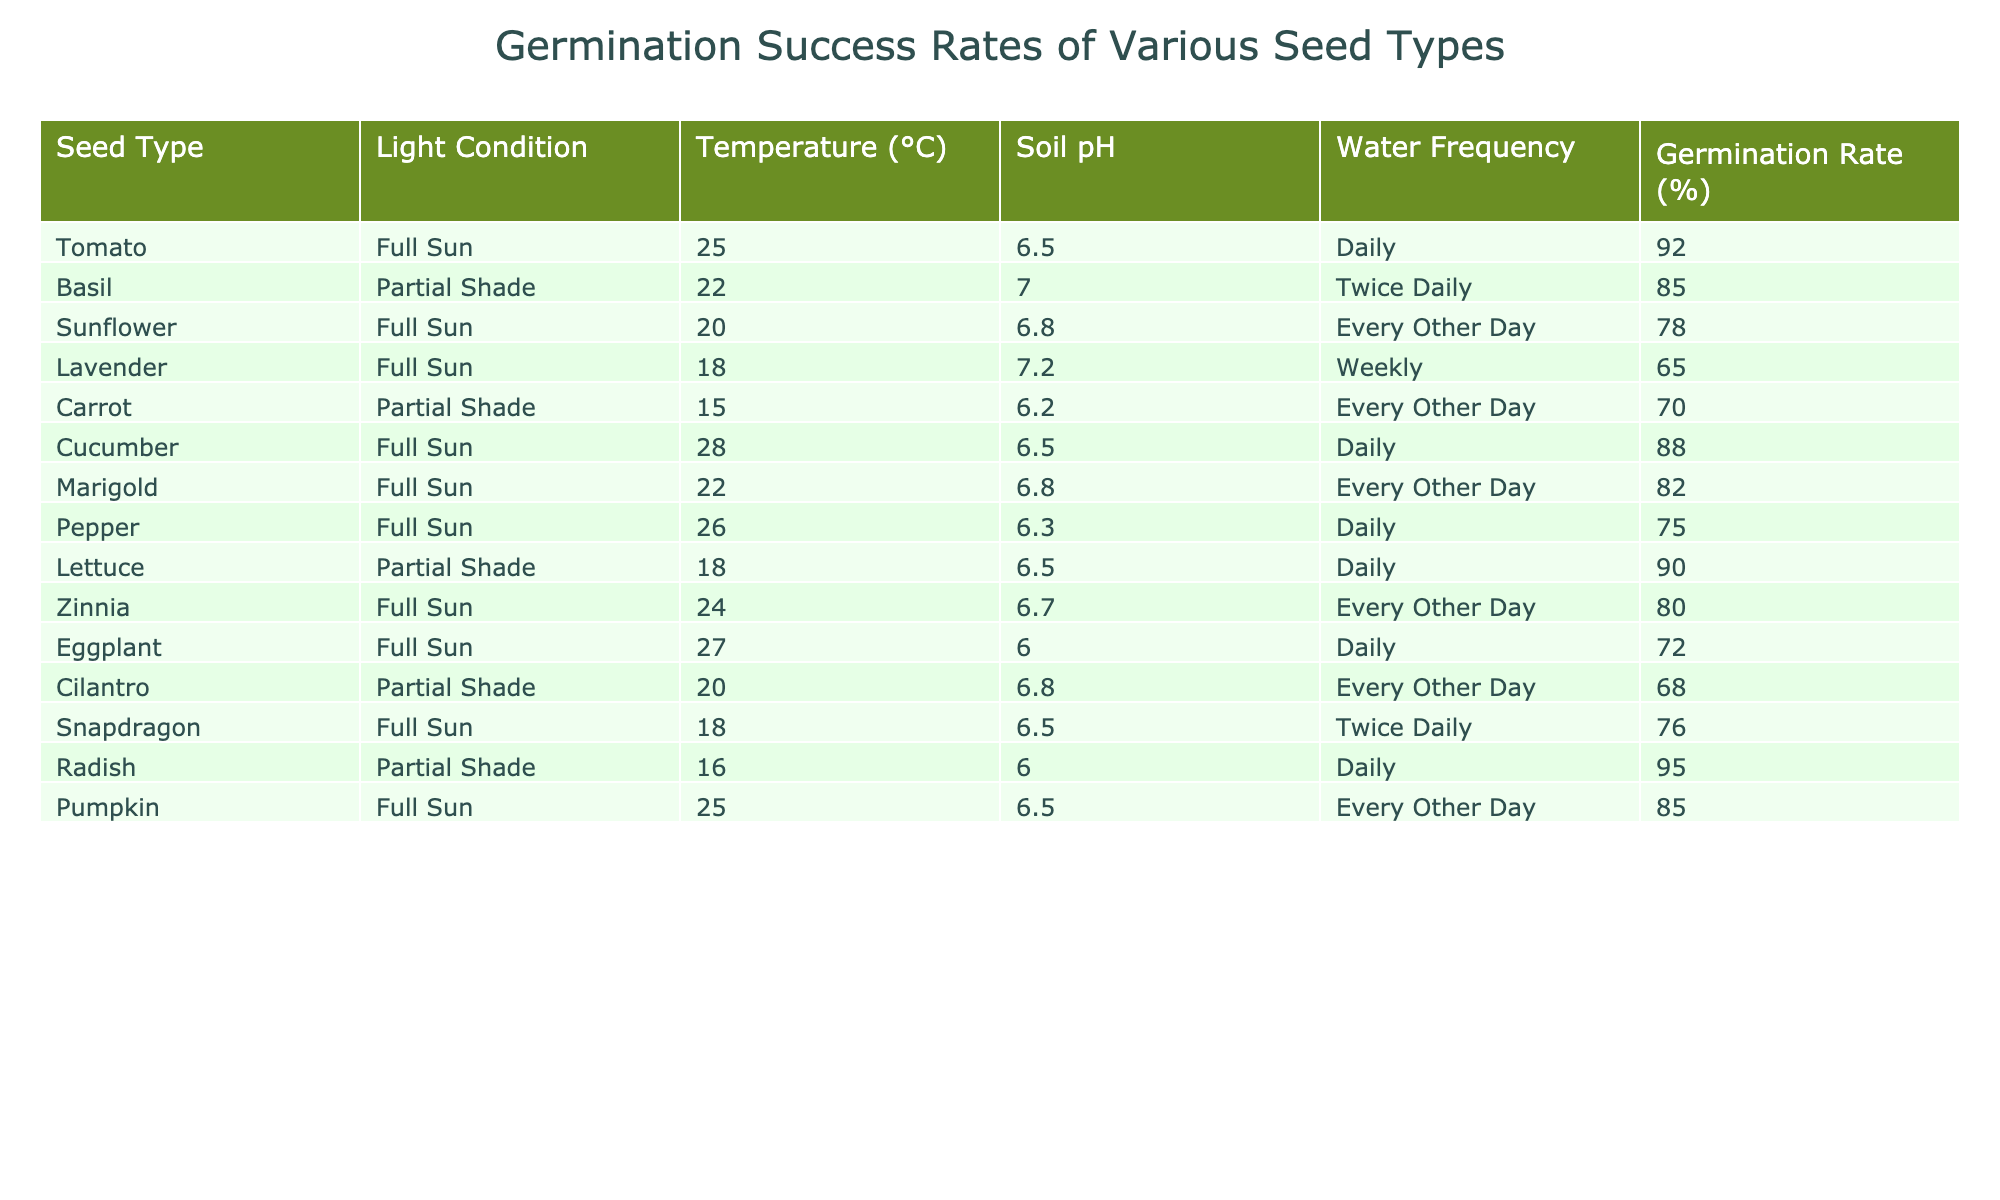What is the germination rate of basil under partial shade? The table shows that the germination rate for basil, which is grown under partial shade, is 85%.
Answer: 85% Which seed type has the highest germination rate? By reviewing the table, tomato has the highest germination rate at 92%.
Answer: 92% Is the germination rate of lettuce higher than that of eggplant? The germination rate for lettuce is 90%, and for eggplant, it is 72%. Since 90% is greater than 72%, the statement is true.
Answer: Yes What is the average germination rate for seeds grown in full sun? The germination rates for seeds in full sun are: 92, 78, 65, 88, 75, 90, 80, 72, and 85. The sum is 765, and there are 9 values, so the average is 765/9 = 85.
Answer: 85 Which seed type grown in partial shade has the highest germination rate? The table indicates that radish, which has a germination rate of 95%, is the highest among the seeds grown in partial shade.
Answer: Radish How does the germination rate of cucumbers compare to carrots? Cucumbers have a germination rate of 88%, while carrots have a rate of 70%. Since 88% is greater than 70%, cucumbers have a higher germination rate.
Answer: Cucumbers are higher What is the difference in germination rates between sunflower and marigold? The germination rate for sunflower is 78%, while for marigold it is 82%. The difference is 82% - 78% = 4%.
Answer: 4% Are all seed types with a germination rate above 80% grown in full sun? The table shows that basil and radish, with rates 85% and 95% respectively, are not grown in full sun (basil is in partial shade). Hence, the statement is false.
Answer: No What is the lowest germination rate recorded for any seed type in this table? By checking the table, the lowest germination rate is for lavender at 65%.
Answer: 65% Which seed types have a germination rate below 75%? The table indicates that lavender (65%), pepper (75%), and cilantro (68%) all have germination rates below 75%.
Answer: Lavender, Pepper, Cilantro What is the total germination rate of all seed types mentioned? The germination rates are 92, 85, 78, 65, 70, 88, 82, 75, 90, 80, 72, 68, 76, 95, and 85. Summing them gives 1,229.
Answer: 1229 